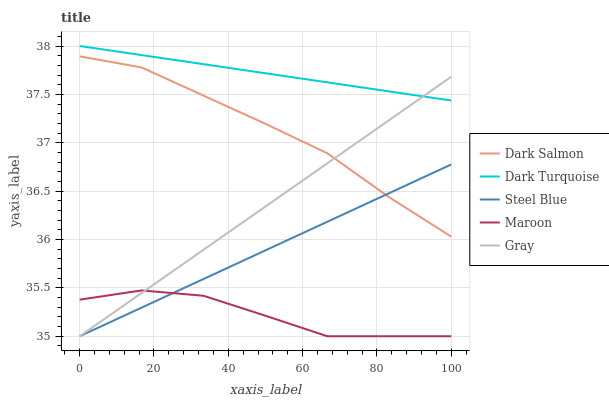Does Maroon have the minimum area under the curve?
Answer yes or no. Yes. Does Dark Turquoise have the maximum area under the curve?
Answer yes or no. Yes. Does Gray have the minimum area under the curve?
Answer yes or no. No. Does Gray have the maximum area under the curve?
Answer yes or no. No. Is Steel Blue the smoothest?
Answer yes or no. Yes. Is Maroon the roughest?
Answer yes or no. Yes. Is Gray the smoothest?
Answer yes or no. No. Is Gray the roughest?
Answer yes or no. No. Does Gray have the lowest value?
Answer yes or no. Yes. Does Dark Salmon have the lowest value?
Answer yes or no. No. Does Dark Turquoise have the highest value?
Answer yes or no. Yes. Does Gray have the highest value?
Answer yes or no. No. Is Steel Blue less than Dark Turquoise?
Answer yes or no. Yes. Is Dark Turquoise greater than Dark Salmon?
Answer yes or no. Yes. Does Maroon intersect Steel Blue?
Answer yes or no. Yes. Is Maroon less than Steel Blue?
Answer yes or no. No. Is Maroon greater than Steel Blue?
Answer yes or no. No. Does Steel Blue intersect Dark Turquoise?
Answer yes or no. No. 